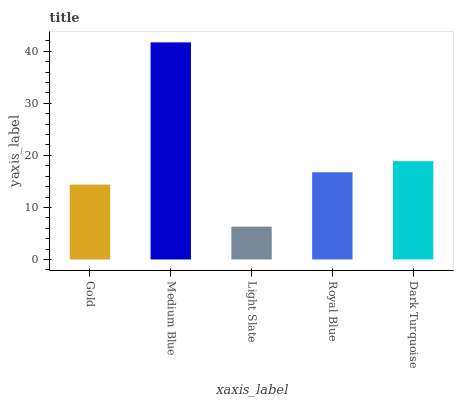Is Light Slate the minimum?
Answer yes or no. Yes. Is Medium Blue the maximum?
Answer yes or no. Yes. Is Medium Blue the minimum?
Answer yes or no. No. Is Light Slate the maximum?
Answer yes or no. No. Is Medium Blue greater than Light Slate?
Answer yes or no. Yes. Is Light Slate less than Medium Blue?
Answer yes or no. Yes. Is Light Slate greater than Medium Blue?
Answer yes or no. No. Is Medium Blue less than Light Slate?
Answer yes or no. No. Is Royal Blue the high median?
Answer yes or no. Yes. Is Royal Blue the low median?
Answer yes or no. Yes. Is Light Slate the high median?
Answer yes or no. No. Is Dark Turquoise the low median?
Answer yes or no. No. 